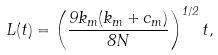Convert formula to latex. <formula><loc_0><loc_0><loc_500><loc_500>L ( t ) = \left ( \frac { 9 k _ { m } ( k _ { m } + c _ { m } ) } { 8 N } \right ) ^ { 1 / 2 } t ,</formula> 